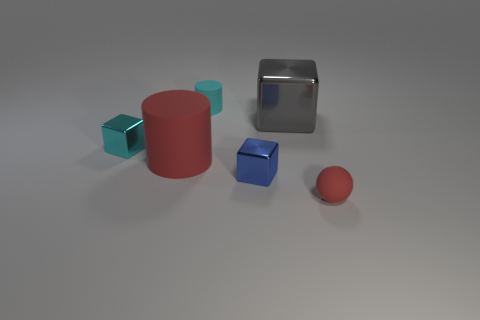There is a tiny matte thing that is left of the matte object in front of the small blue metallic block; what number of large red objects are in front of it?
Your answer should be very brief. 1. How many small cyan metallic cubes are behind the small blue shiny thing?
Offer a very short reply. 1. What is the color of the small object to the left of the tiny matte thing behind the red cylinder?
Ensure brevity in your answer.  Cyan. How many other things are the same material as the tiny red object?
Offer a terse response. 2. Are there the same number of cubes that are to the right of the cyan matte thing and tiny things?
Give a very brief answer. No. What is the material of the cyan thing that is behind the small shiny thing behind the cylinder that is in front of the large gray metal thing?
Provide a succinct answer. Rubber. What color is the metallic thing that is on the left side of the tiny cyan matte object?
Make the answer very short. Cyan. Are there any other things that are the same shape as the small red rubber object?
Offer a terse response. No. What is the size of the matte cylinder to the left of the small cyan matte object that is behind the rubber sphere?
Your answer should be very brief. Large. Are there the same number of cyan cubes to the right of the gray thing and tiny cyan cubes to the right of the cyan metal thing?
Offer a very short reply. Yes. 